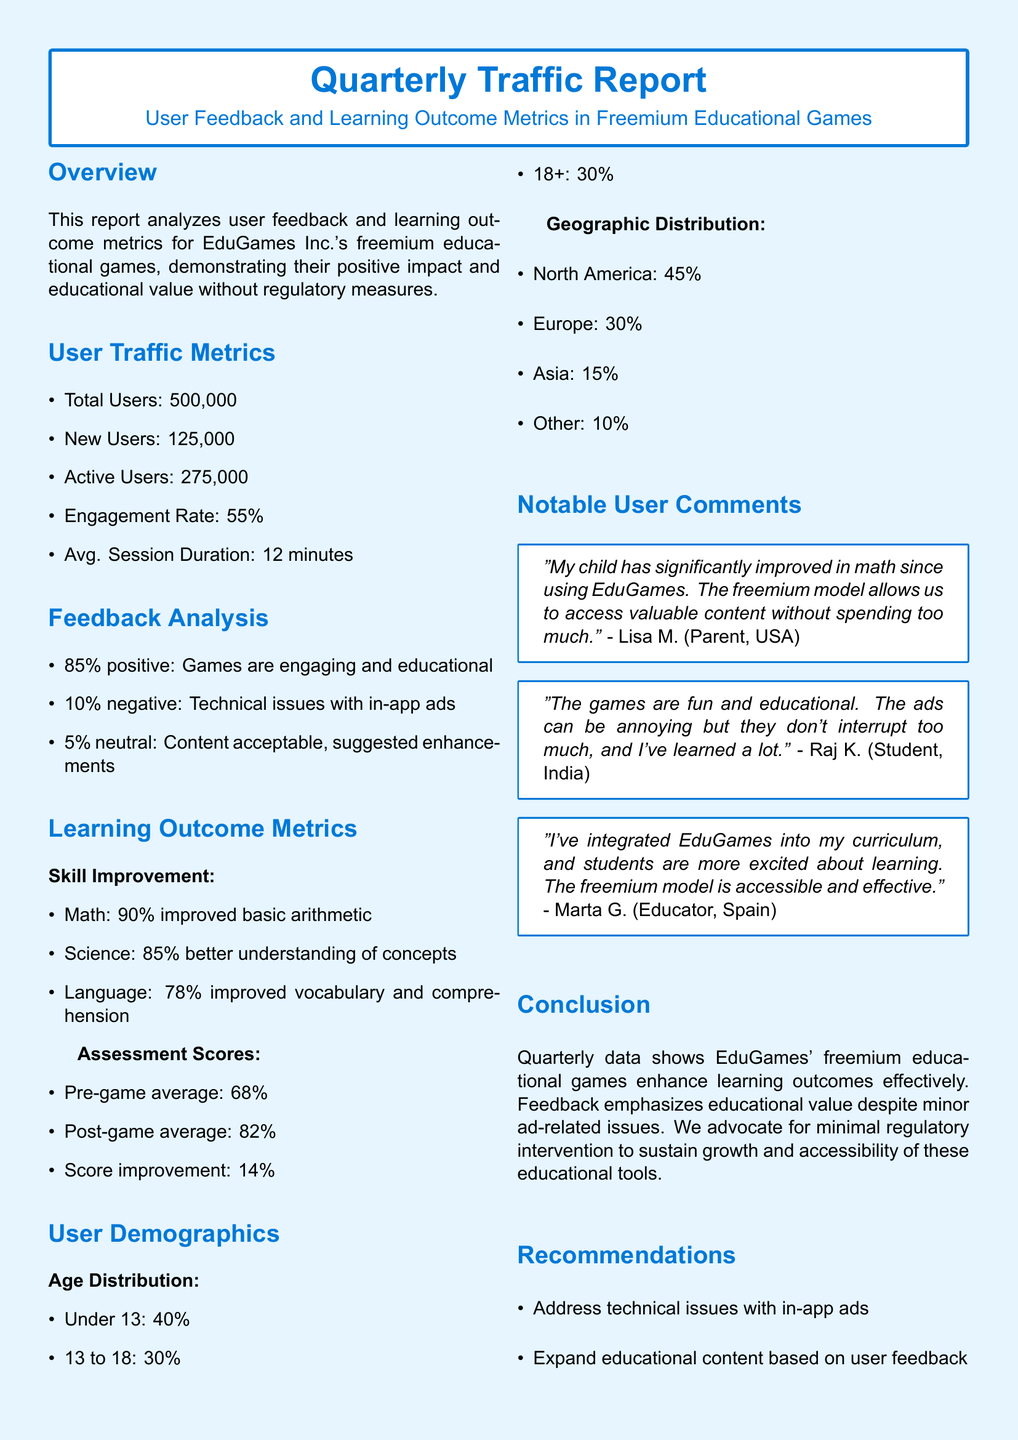What is the total number of users? The total number of users is stated directly in the user traffic metrics section of the document.
Answer: 500,000 What percentage of users reported positive feedback? The percentage of positive feedback is provided in the feedback analysis section, showing user sentiments.
Answer: 85% What is the engagement rate noted in the report? The engagement rate is specified within the user traffic metrics, indicating user interaction with the educational games.
Answer: 55% What was the average session duration for users? This information can be found in the user traffic metrics section, reflecting how long users engage with the games.
Answer: 12 minutes What was the pre-game average assessment score? The pre-game average score is detailed in the learning outcome metrics, showing the learners' initial performance.
Answer: 68% What was the improvement in math skill percentage? The improvement in math skills is listed under skill improvement in learning outcome metrics, showing progress made by users.
Answer: 90% What age group comprises 40% of the user demographics? The age group percentage is indicated in the user demographics section, categorizing users by age.
Answer: Under 13 What issue was highlighted by 10% of users in feedback? The feedback analysis section outlines specific concerns expressed by users, indicating a minor issue affecting user experience.
Answer: Technical issues with in-app ads What is one key recommendation from the report? Recommendations are presented at the end of the report based on user feedback and learning outcomes.
Answer: Address technical issues with in-app ads 